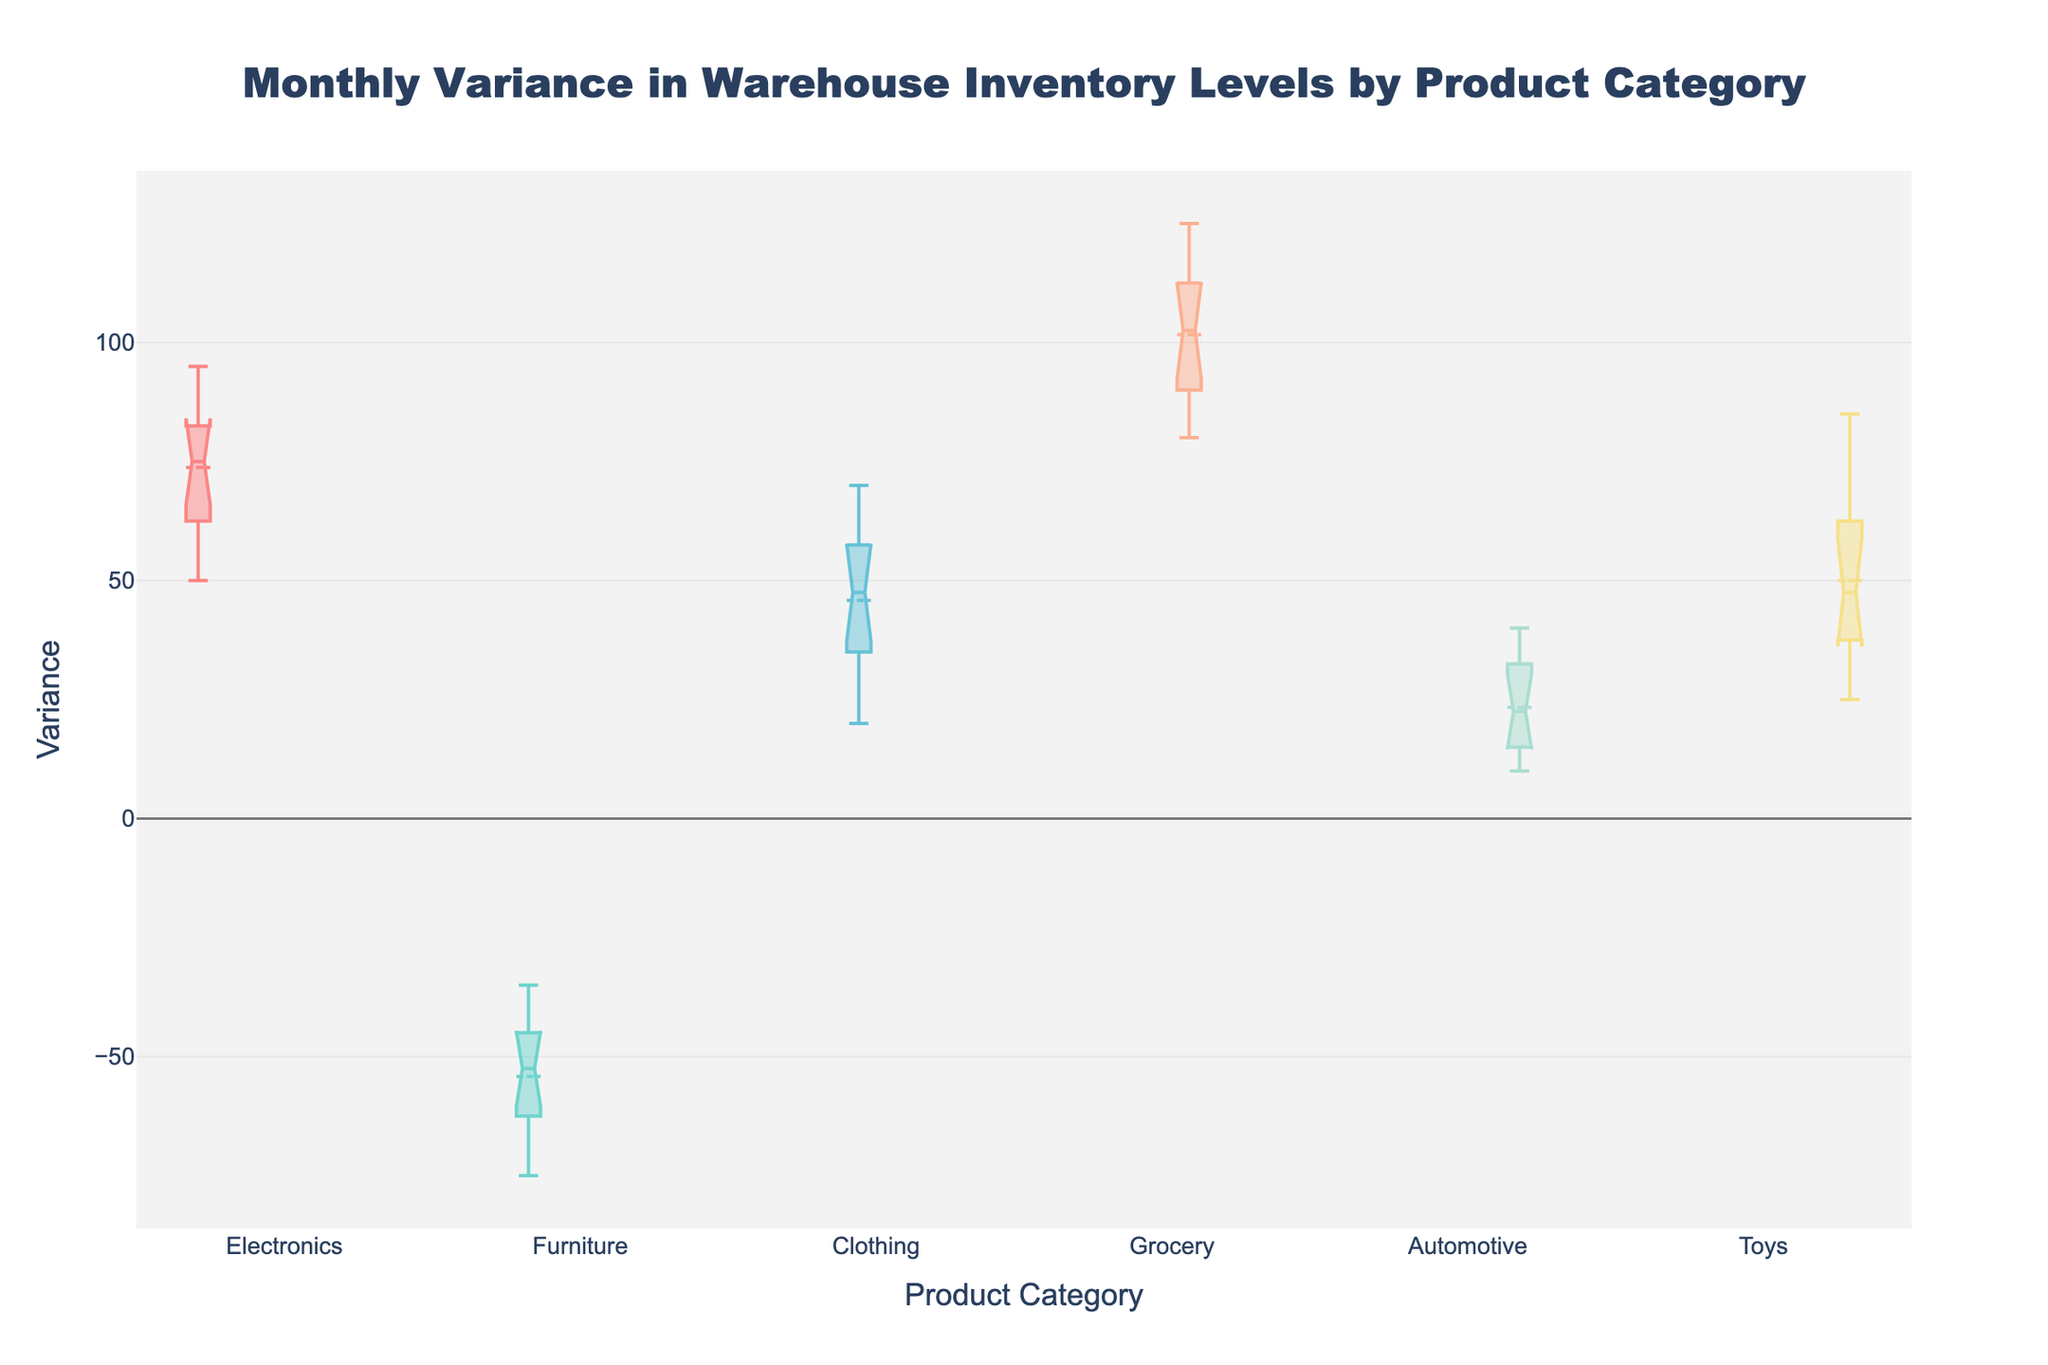What is the title of the plot? The title of the plot is located at the top center of the figure. It reads: "Monthly Variance in Warehouse Inventory Levels by Product Category".
Answer: Monthly Variance in Warehouse Inventory Levels by Product Category Which product category has the highest median variance? To find the product category with the highest median variance, look at the dashed lines inside each box. The median is the line within the notched area, and Grocery has the highest median value.
Answer: Grocery What is the range of variance values for the Electronics category? The range of variance values can be determined by the length of the box and whiskers. For Electronics, the variance ranges approximately from 50 to 95.
Answer: 50 to 95 Which product category shows the most negative variance? Look at the box representing the variance for each category. Furniture has the most negative variance, with values primarily below zero.
Answer: Furniture Among the categories, which has a larger interquartile range (IQR): Clothing or Automotive? The IQR is the length of the box. Comparing the boxes of Clothing and Automotive, Clothing has a visibly larger box, indicating a larger IQR.
Answer: Clothing What is the difference in median variance between Electronics and Toys? The median variance for Electronics is about 75, and for Toys, it is about 50. The difference is 75 - 50 = 25.
Answer: 25 Is there a category with no notches overlapping with any other category? Notched boxes that do not overlap suggest a significant difference in medians. The Furniture category does not have overlapping notches with any other category, indicating significant differences in its median variance.
Answer: Furniture Which product category has the widest notch? The notch width represents the confidence interval for the median. The Toys category has the widest notch.
Answer: Toys What is the mean variance for the Electronics category? Inside the box for the Electronics category, there is a point representing the mean, which is approximately at 75.
Answer: 75 